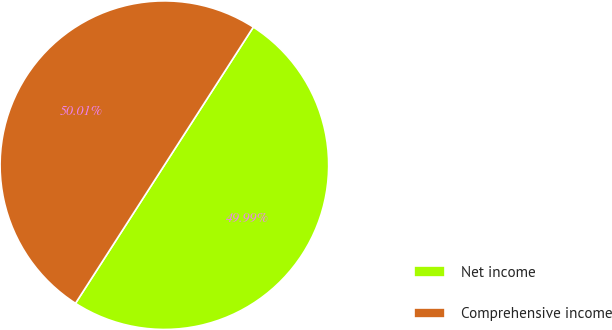Convert chart to OTSL. <chart><loc_0><loc_0><loc_500><loc_500><pie_chart><fcel>Net income<fcel>Comprehensive income<nl><fcel>49.99%<fcel>50.01%<nl></chart> 